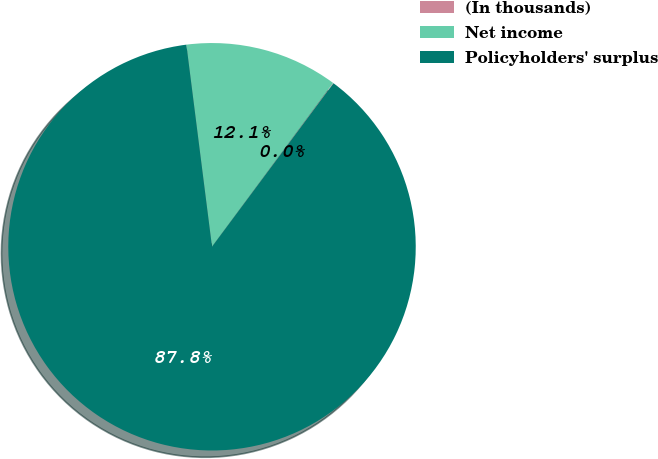Convert chart. <chart><loc_0><loc_0><loc_500><loc_500><pie_chart><fcel>(In thousands)<fcel>Net income<fcel>Policyholders' surplus<nl><fcel>0.04%<fcel>12.14%<fcel>87.82%<nl></chart> 